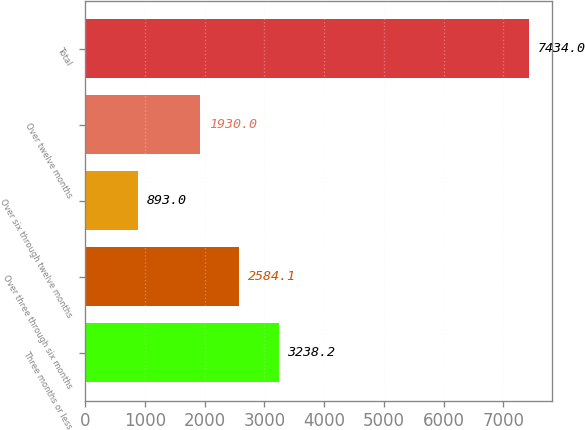Convert chart to OTSL. <chart><loc_0><loc_0><loc_500><loc_500><bar_chart><fcel>Three months or less<fcel>Over three through six months<fcel>Over six through twelve months<fcel>Over twelve months<fcel>Total<nl><fcel>3238.2<fcel>2584.1<fcel>893<fcel>1930<fcel>7434<nl></chart> 